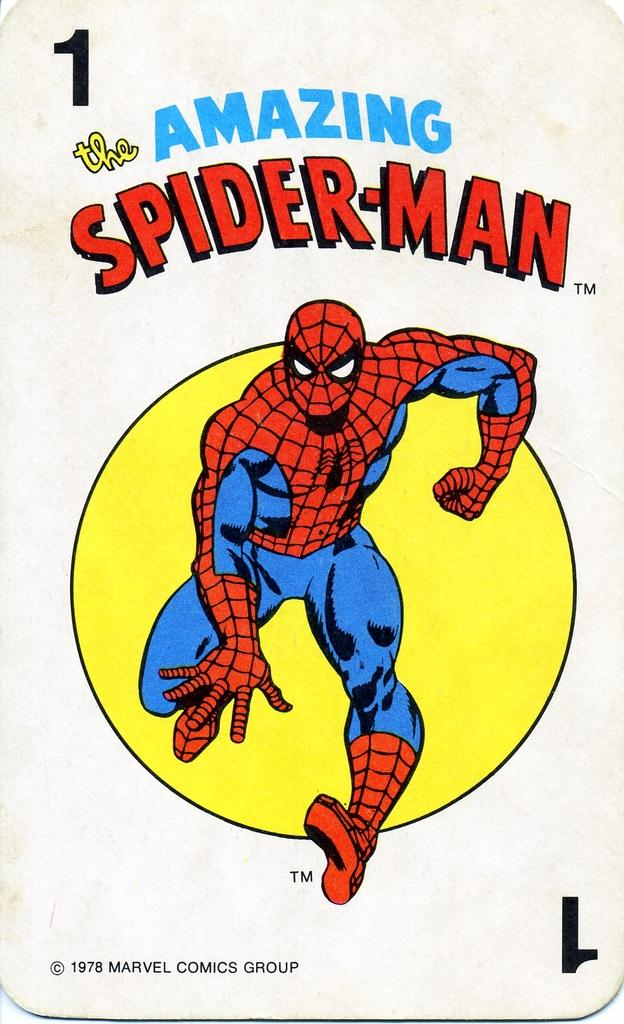What character is depicted in the image? There is a depiction of Spider-Man in the image. What else can be seen in the image besides the character? There is text and a number present in the image. How does society impact the journey of the crack in the image? There is no mention of society, journey, or crack in the image. The image features a depiction of Spider-Man, text, and a number. 